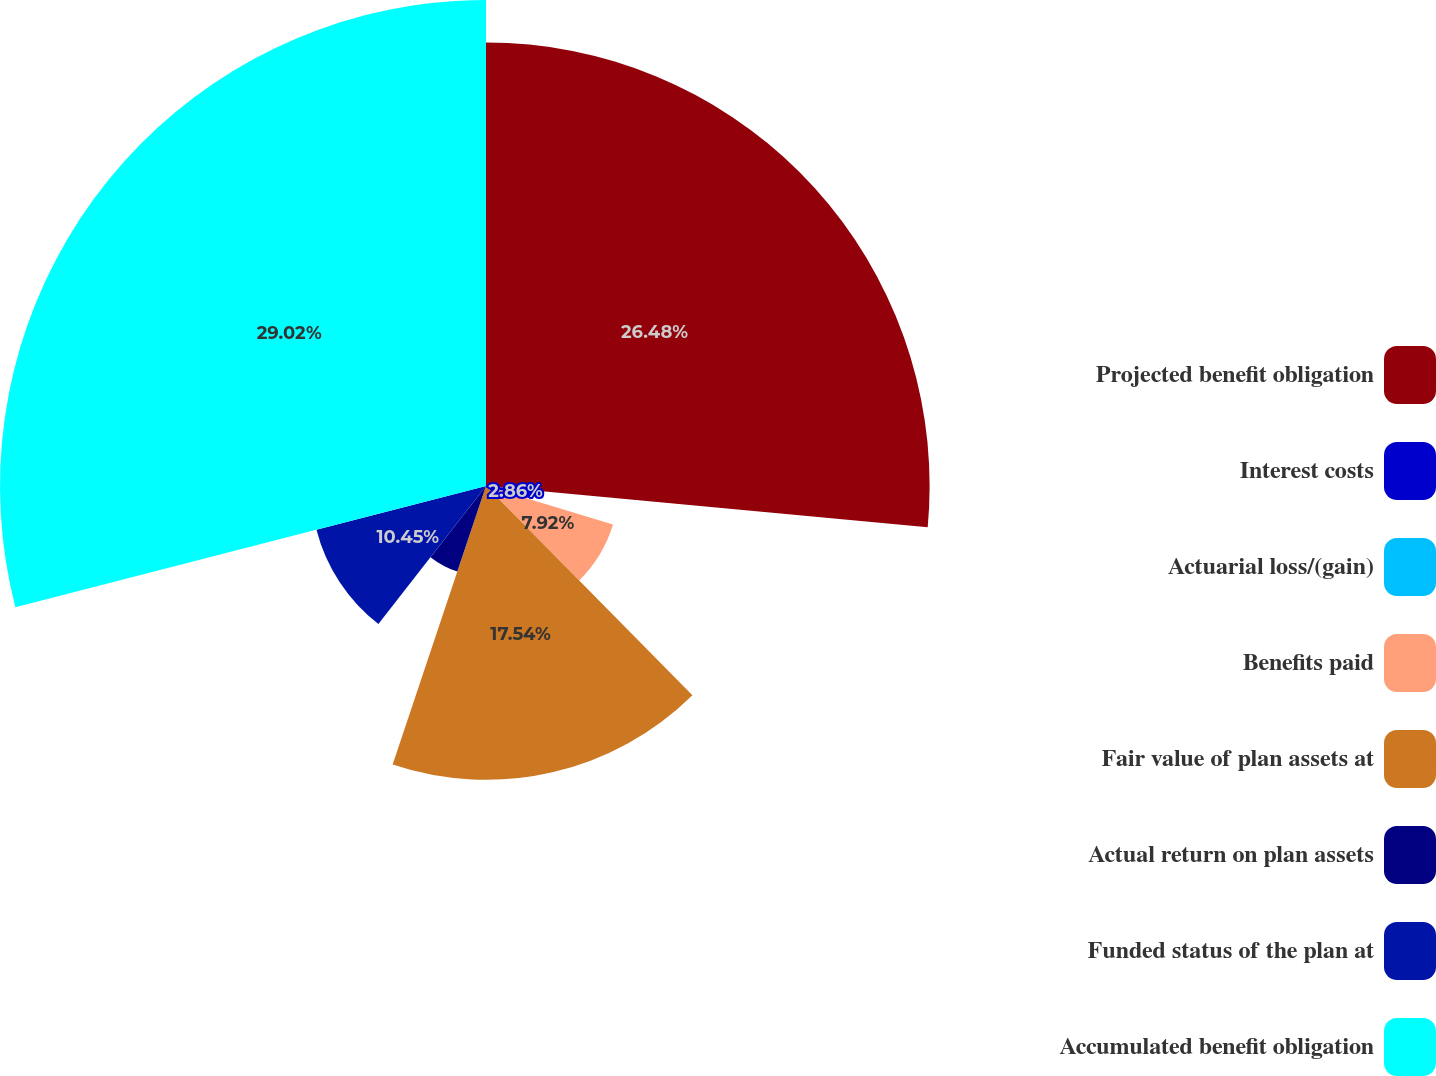Convert chart to OTSL. <chart><loc_0><loc_0><loc_500><loc_500><pie_chart><fcel>Projected benefit obligation<fcel>Interest costs<fcel>Actuarial loss/(gain)<fcel>Benefits paid<fcel>Fair value of plan assets at<fcel>Actual return on plan assets<fcel>Funded status of the plan at<fcel>Accumulated benefit obligation<nl><fcel>26.48%<fcel>2.86%<fcel>0.34%<fcel>7.92%<fcel>17.54%<fcel>5.39%<fcel>10.45%<fcel>29.01%<nl></chart> 